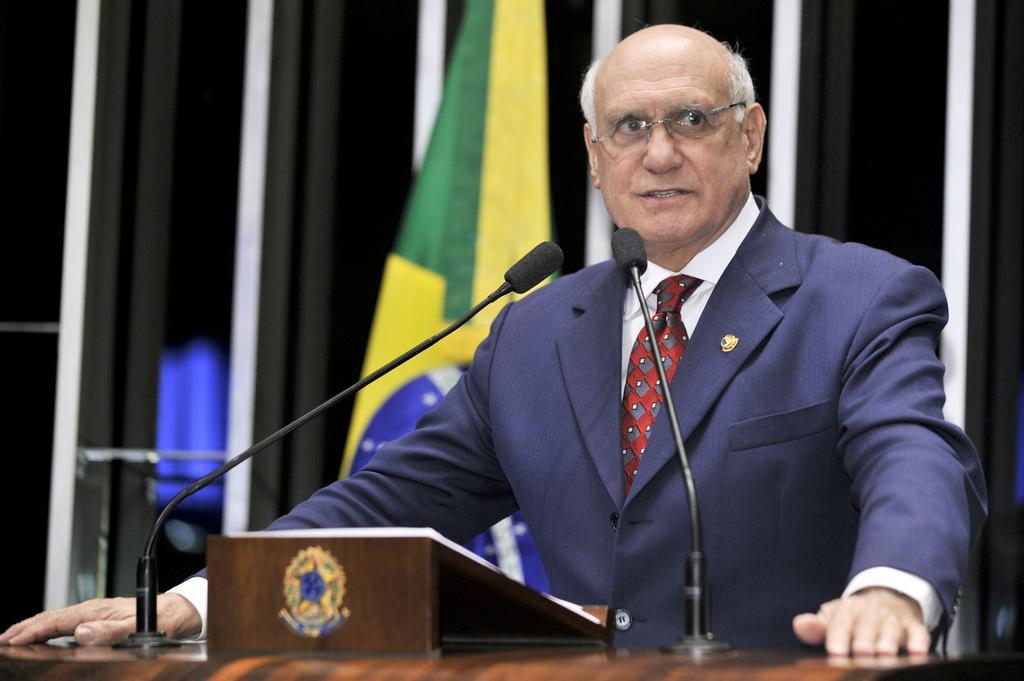How would you summarize this image in a sentence or two? This image is taken indoors. At the bottom of the image there is a podium with mics. In the middle of the image a man is standing. In the background there is a wall and a flag. He has worn a coat, a tie and a shirt. 